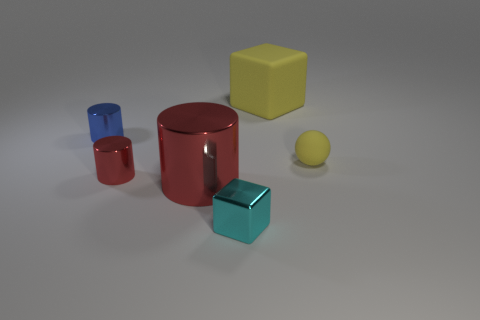Subtract all big red cylinders. How many cylinders are left? 2 Subtract all blue cylinders. How many cylinders are left? 2 Add 3 small metallic cylinders. How many objects exist? 9 Subtract 2 cylinders. How many cylinders are left? 1 Subtract all yellow cubes. Subtract all gray balls. How many cubes are left? 1 Subtract all blue cylinders. How many cyan spheres are left? 0 Subtract all small purple metal cylinders. Subtract all cyan things. How many objects are left? 5 Add 4 yellow rubber cubes. How many yellow rubber cubes are left? 5 Add 3 tiny gray metallic cylinders. How many tiny gray metallic cylinders exist? 3 Subtract 0 gray spheres. How many objects are left? 6 